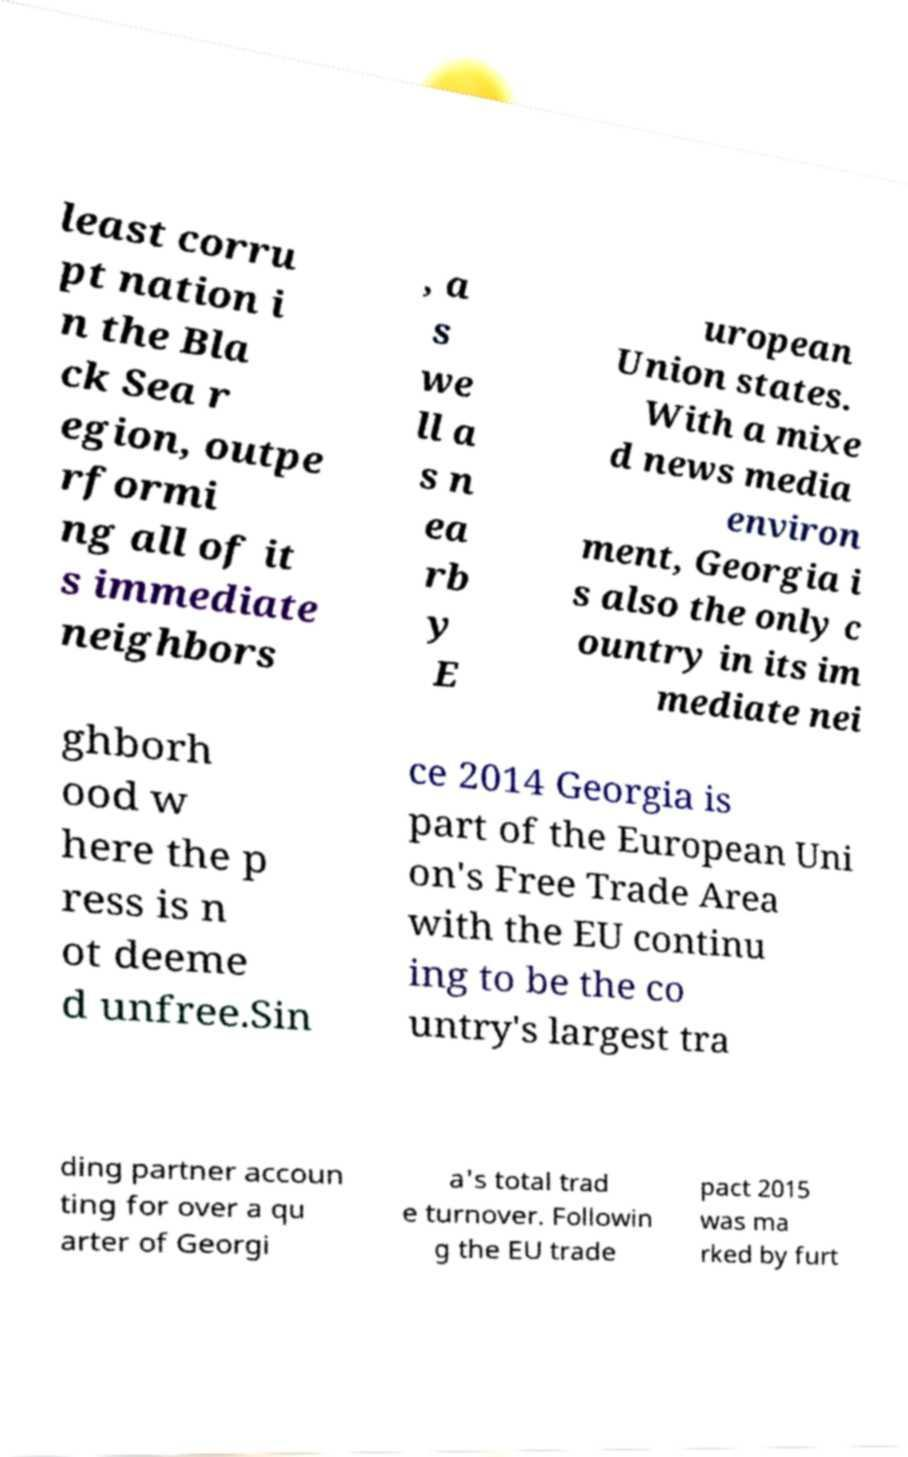I need the written content from this picture converted into text. Can you do that? least corru pt nation i n the Bla ck Sea r egion, outpe rformi ng all of it s immediate neighbors , a s we ll a s n ea rb y E uropean Union states. With a mixe d news media environ ment, Georgia i s also the only c ountry in its im mediate nei ghborh ood w here the p ress is n ot deeme d unfree.Sin ce 2014 Georgia is part of the European Uni on's Free Trade Area with the EU continu ing to be the co untry's largest tra ding partner accoun ting for over a qu arter of Georgi a's total trad e turnover. Followin g the EU trade pact 2015 was ma rked by furt 